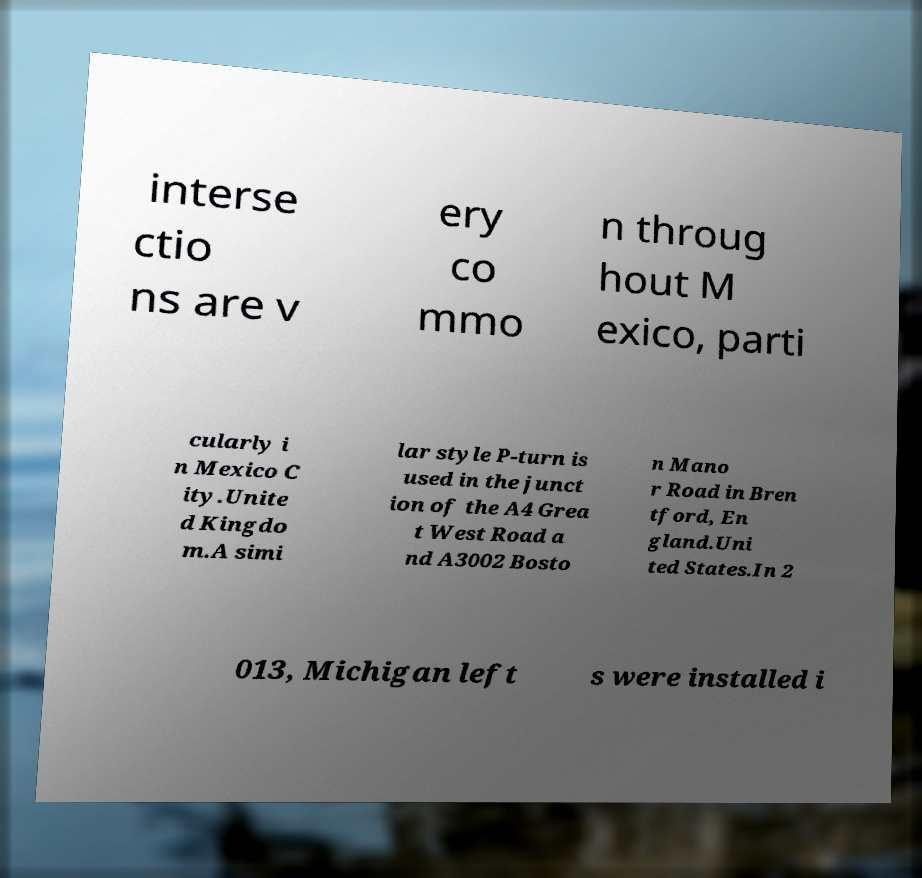Please identify and transcribe the text found in this image. interse ctio ns are v ery co mmo n throug hout M exico, parti cularly i n Mexico C ity.Unite d Kingdo m.A simi lar style P-turn is used in the junct ion of the A4 Grea t West Road a nd A3002 Bosto n Mano r Road in Bren tford, En gland.Uni ted States.In 2 013, Michigan left s were installed i 